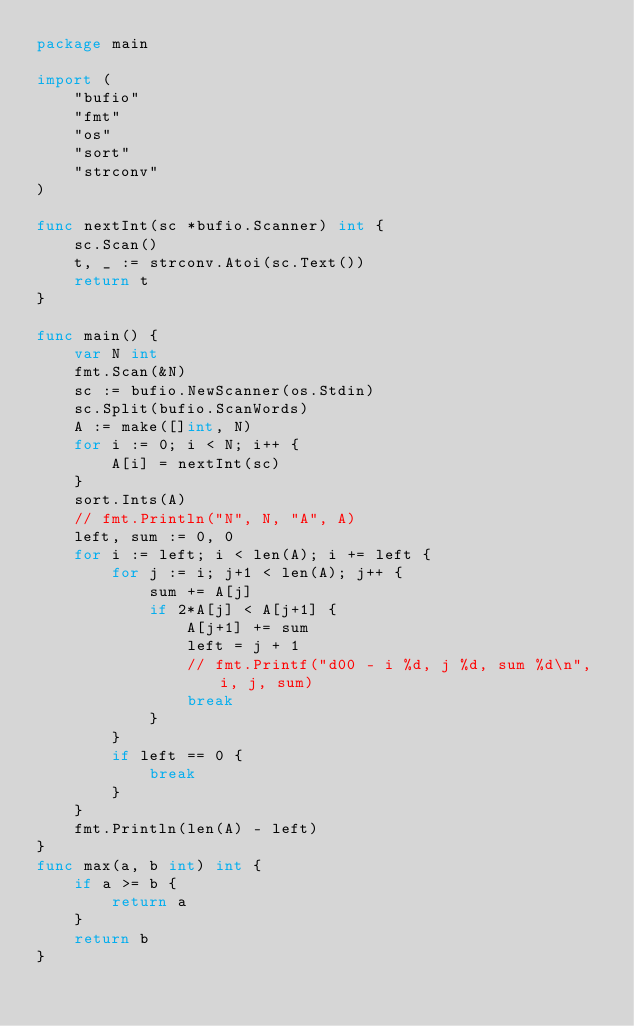Convert code to text. <code><loc_0><loc_0><loc_500><loc_500><_Go_>package main

import (
	"bufio"
	"fmt"
	"os"
	"sort"
	"strconv"
)

func nextInt(sc *bufio.Scanner) int {
	sc.Scan()
	t, _ := strconv.Atoi(sc.Text())
	return t
}

func main() {
	var N int
	fmt.Scan(&N)
	sc := bufio.NewScanner(os.Stdin)
	sc.Split(bufio.ScanWords)
	A := make([]int, N)
	for i := 0; i < N; i++ {
		A[i] = nextInt(sc)
	}
	sort.Ints(A)
	// fmt.Println("N", N, "A", A)
	left, sum := 0, 0
	for i := left; i < len(A); i += left {
		for j := i; j+1 < len(A); j++ {
			sum += A[j]
			if 2*A[j] < A[j+1] {
				A[j+1] += sum
				left = j + 1
				// fmt.Printf("d00 - i %d, j %d, sum %d\n", i, j, sum)
				break
			}
		}
		if left == 0 {
			break
		}
	}
	fmt.Println(len(A) - left)
}
func max(a, b int) int {
	if a >= b {
		return a
	}
	return b
}
</code> 